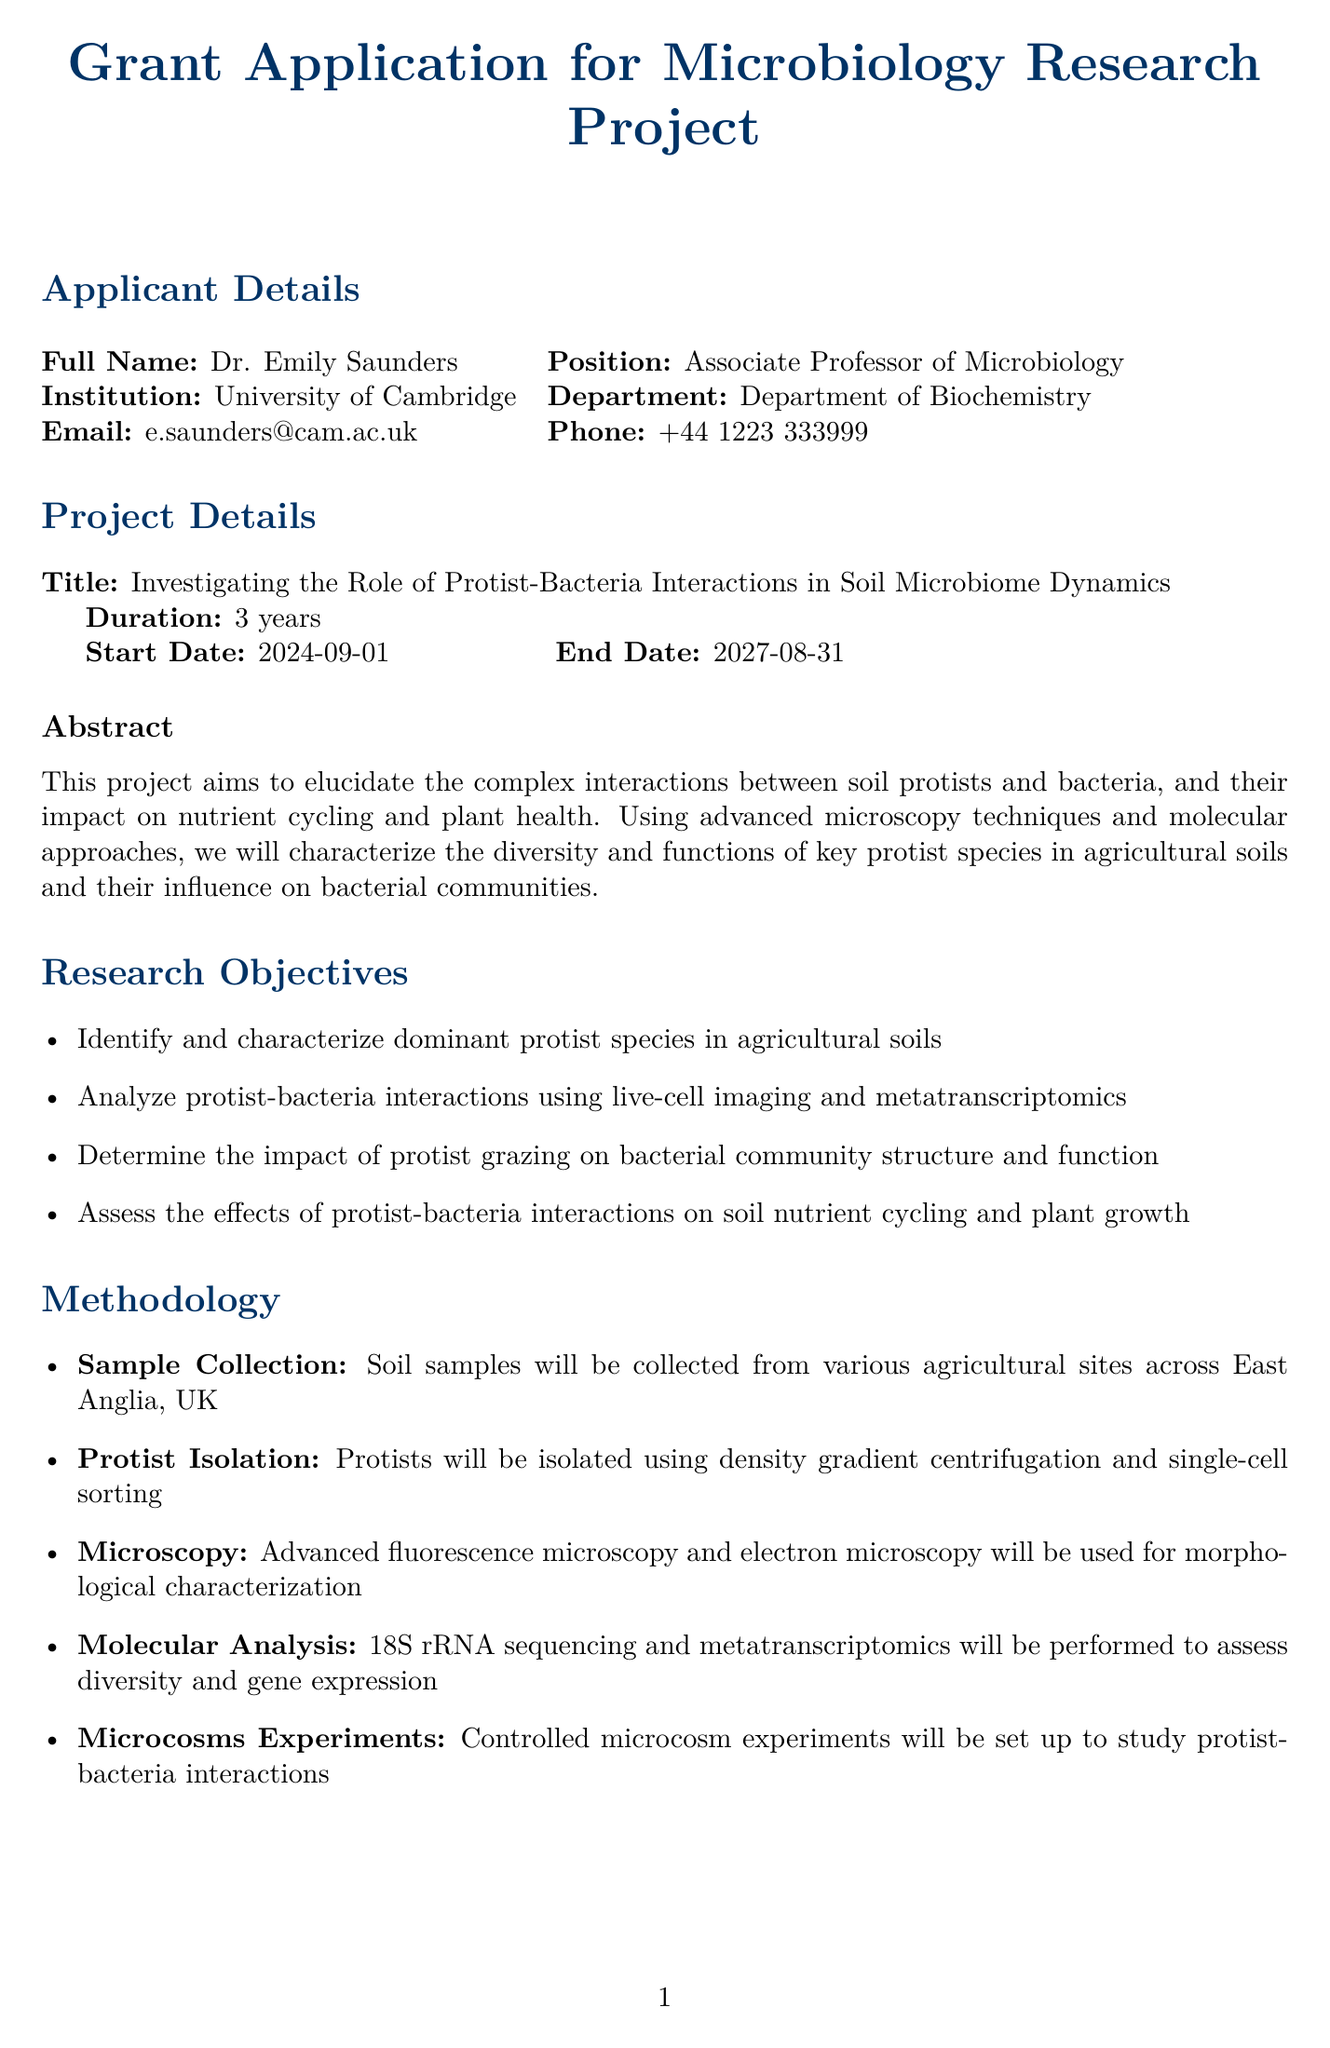what is the title of the project? The title of the project is mentioned under Project Details, which is focused on protist-bacteria interactions in soil microbiome dynamics.
Answer: Investigating the Role of Protist-Bacteria Interactions in Soil Microbiome Dynamics who is the lead applicant? The lead applicant's full name is provided in the Applicant Details section of the document.
Answer: Dr. Emily Saunders what is the start date of the project? The start date is indicated in the Project Details, specifying when the project is set to begin.
Answer: 2024-09-01 what is the total funding requested for the project? The total funding requested is clearly stated in the Budget Breakdown section of the document.
Answer: 900000 how many years will the project last? The project duration is indicated in the Project Details section.
Answer: 3 years which institution is collaborating on the project? Collaborating institutions are listed in the Collaborators section, which details the names and expertise of collaborating professionals.
Answer: University of East Anglia what are the expected outcomes of the research? The expected outcomes are listed under a specific section of the document, outlining what the project aims to achieve.
Answer: Comprehensive catalogue of soil protist diversity in agricultural ecosystems which microscopy techniques will be used in the project? The methodology section describes the specific techniques and approaches planned to be employed in the research.
Answer: Advanced fluorescence microscopy and electron microscopy what are the ethical considerations mentioned in the project? Ethical considerations are presented after the main project information, addressing compliance and testing norms.
Answer: This project involves no animal testing or human subjects 